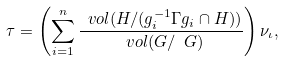Convert formula to latex. <formula><loc_0><loc_0><loc_500><loc_500>\tau = \left ( \sum _ { i = 1 } ^ { n } \frac { \ v o l ( H / ( g _ { i } ^ { - 1 } \Gamma g _ { i } \cap H ) ) } { \ v o l ( G / \ G ) } \right ) \nu _ { \iota } ,</formula> 